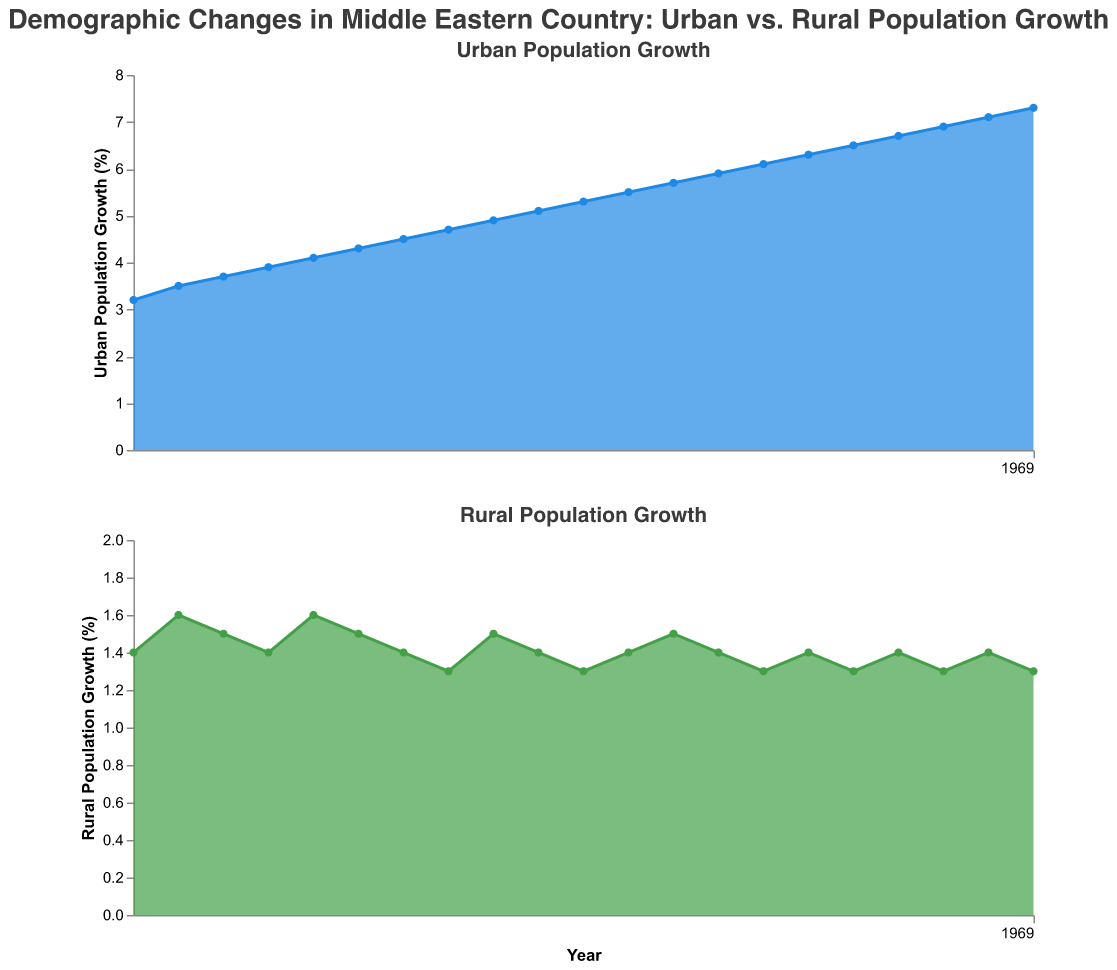What is the title of the figure? The title of the figure is located at the top and provides an overview of the visualized data. In this case, the title reads "Demographic Changes in Middle Eastern Country: Urban vs. Rural Population Growth."
Answer: Demographic Changes in Middle Eastern Country: Urban vs. Rural Population Growth Between urban and rural population growth, which has the higher growth rate in 2020? Referencing the y-axis values for both urban and rural population growth in 2020, urban growth is at 7.3% while rural growth is at 1.3%.
Answer: Urban What is the trend of urban population growth from 2000 to 2020? Observe the pattern of urban population growth in the plotted area for the years 2000 to 2020. The growth rate consistently increases from 3.2% in 2000 to 7.3% in 2020.
Answer: Increasing What year had the highest rural population growth? By examining the y-axis values across the years for the rural population growth subplot, you can see that the highest value of 1.6% occurs in the years 2001 and 2004.
Answer: 2001 and 2004 Compare the urban population growth in 2005 and 2015. Which year had a higher growth rate and by how much? Check the y-axis values for urban population growth in 2005 (4.3%) and 2015 (6.3%). The growth rate in 2015 is higher. Subtracting the 2005 value from the 2015 value gives the difference: 6.3 - 4.3 = 2.0%.
Answer: 2015, by 2.0% What is the average rural population growth from 2010 to 2020? Calculate the average by summing the rural growth rates from 2010 to 2020 (1.3, 1.4, 1.5, 1.4, 1.3, 1.4, 1.3, 1.4, 1.3, 1.4, and 1.3) and dividing by the number of years. (1.3+1.4+1.5+1.4+1.3+1.4+1.3+1.4+1.3+1.4+1.3) / 11 = 1.37.
Answer: 1.37% How does the lowest urban population growth rate compare to the highest rural population growth rate? The lowest urban growth rate is 3.2% in 2000, and the highest rural growth rate is 1.6% in 2001 and 2004. The urban rate is still higher than the rural rate.
Answer: Urban growth rate is higher What is the overall trend for rural population growth from 2000 to 2020? Analyzing the y-axis values of rural population from 2000 to 2020, the growth rate fluctuates slightly but does not show a significant upward or downward trend, staying around 1.3-1.6%.
Answer: Relatively stable In which year did both urban and rural population growth increase by the same rate, and what was that rate? By comparing the growth rates in each year for both urban and rural populations, in 2001 both increased by 0.2% compared to the previous year.
Answer: 2001, 0.2% 